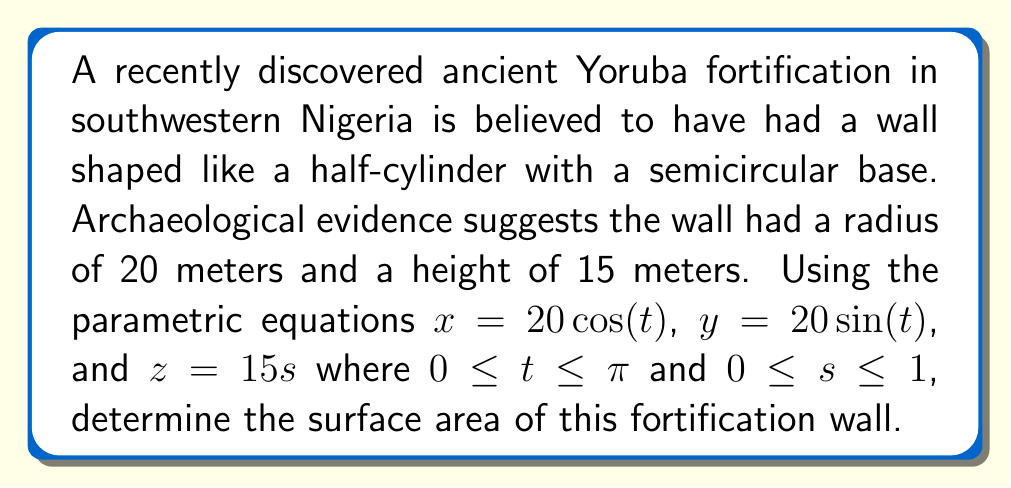Teach me how to tackle this problem. To find the surface area of the cylindrical wall, we need to use the surface area formula for parametric surfaces:

$$A = \int\int \sqrt{({\frac{\partial x}{\partial t}}{\frac{\partial y}{\partial s}} - {\frac{\partial x}{\partial s}}{\frac{\partial y}{\partial t}})^2 + ({\frac{\partial y}{\partial t}}{\frac{\partial z}{\partial s}} - {\frac{\partial y}{\partial s}}{\frac{\partial z}{\partial t}})^2 + ({\frac{\partial z}{\partial t}}{\frac{\partial x}{\partial s}} - {\frac{\partial z}{\partial s}}{\frac{\partial x}{\partial t}})^2} \, dt \, ds$$

Step 1: Calculate the partial derivatives:
$\frac{\partial x}{\partial t} = -20\sin(t)$, $\frac{\partial x}{\partial s} = 0$
$\frac{\partial y}{\partial t} = 20\cos(t)$, $\frac{\partial y}{\partial s} = 0$
$\frac{\partial z}{\partial t} = 0$, $\frac{\partial z}{\partial s} = 15$

Step 2: Substitute these values into the surface area formula:

$$A = \int_0^1 \int_0^\pi \sqrt{(0 - 0)^2 + (20\cos(t) \cdot 15 - 0)^2 + (-15 \cdot -20\sin(t) - 0)^2} \, dt \, ds$$

Step 3: Simplify the expression under the square root:

$$A = \int_0^1 \int_0^\pi \sqrt{(300\cos(t))^2 + (300\sin(t))^2} \, dt \, ds$$

$$A = \int_0^1 \int_0^\pi \sqrt{90000(\cos^2(t) + \sin^2(t))} \, dt \, ds$$

$$A = \int_0^1 \int_0^\pi \sqrt{90000} \, dt \, ds = 300 \int_0^1 \int_0^\pi 1 \, dt \, ds$$

Step 4: Evaluate the double integral:

$$A = 300 \cdot 1 \cdot \pi = 300\pi$$

Therefore, the surface area of the fortification wall is $300\pi$ square meters.
Answer: $300\pi$ m² 